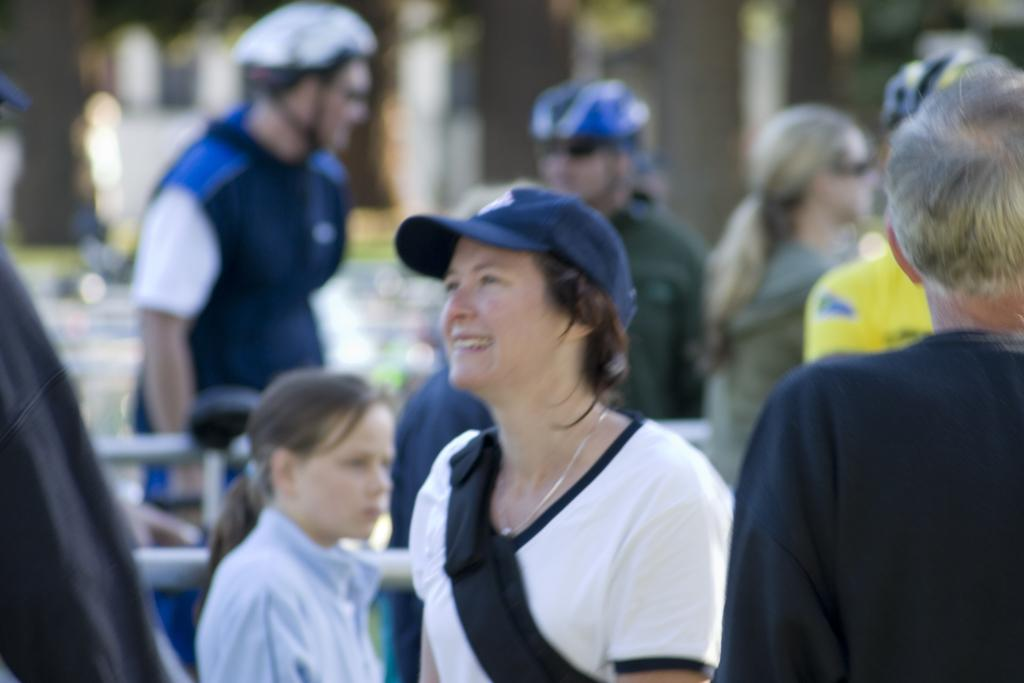What can be seen in the image? There are people standing in the image. Can you describe the clothing of the people? The people are wearing different color dresses. What is the condition of the background in the image? The background of the image is blurred. How many pigs are present in the image? There are no pigs present in the image; it features people wearing different color dresses. What type of society is depicted in the image? The image does not depict a specific society; it simply shows people standing and wearing different color dresses. 